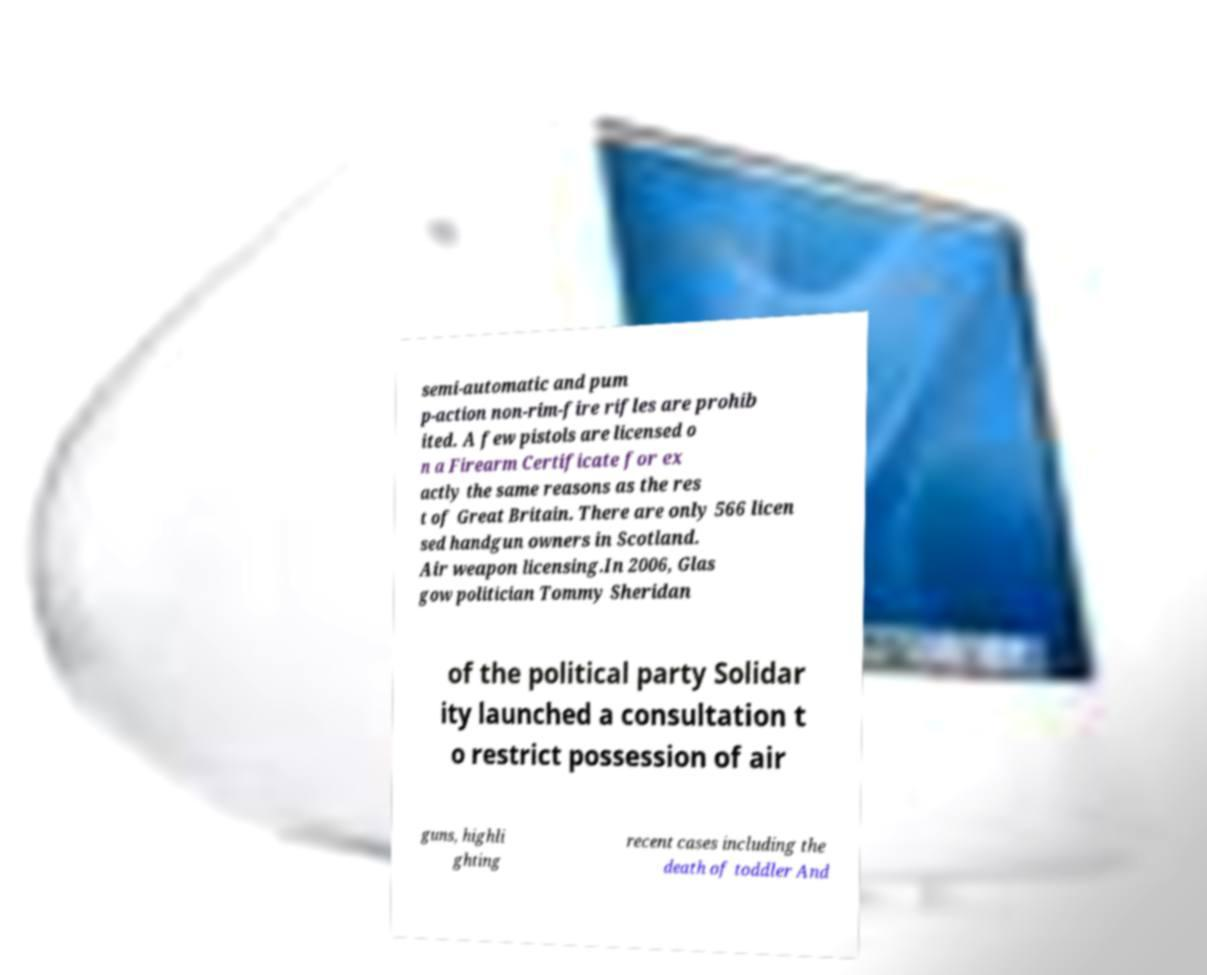Could you assist in decoding the text presented in this image and type it out clearly? semi-automatic and pum p-action non-rim-fire rifles are prohib ited. A few pistols are licensed o n a Firearm Certificate for ex actly the same reasons as the res t of Great Britain. There are only 566 licen sed handgun owners in Scotland. Air weapon licensing.In 2006, Glas gow politician Tommy Sheridan of the political party Solidar ity launched a consultation t o restrict possession of air guns, highli ghting recent cases including the death of toddler And 